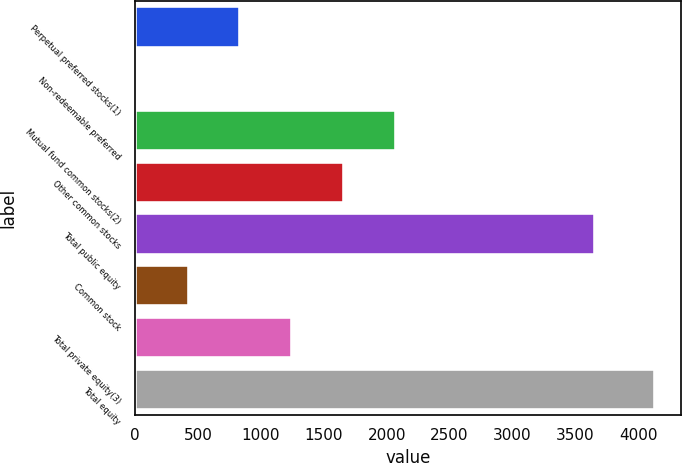<chart> <loc_0><loc_0><loc_500><loc_500><bar_chart><fcel>Perpetual preferred stocks(1)<fcel>Non-redeemable preferred<fcel>Mutual fund common stocks(2)<fcel>Other common stocks<fcel>Total public equity<fcel>Common stock<fcel>Total private equity(3)<fcel>Total equity<nl><fcel>837.4<fcel>13<fcel>2074<fcel>1661.8<fcel>3656<fcel>425.2<fcel>1249.6<fcel>4135<nl></chart> 